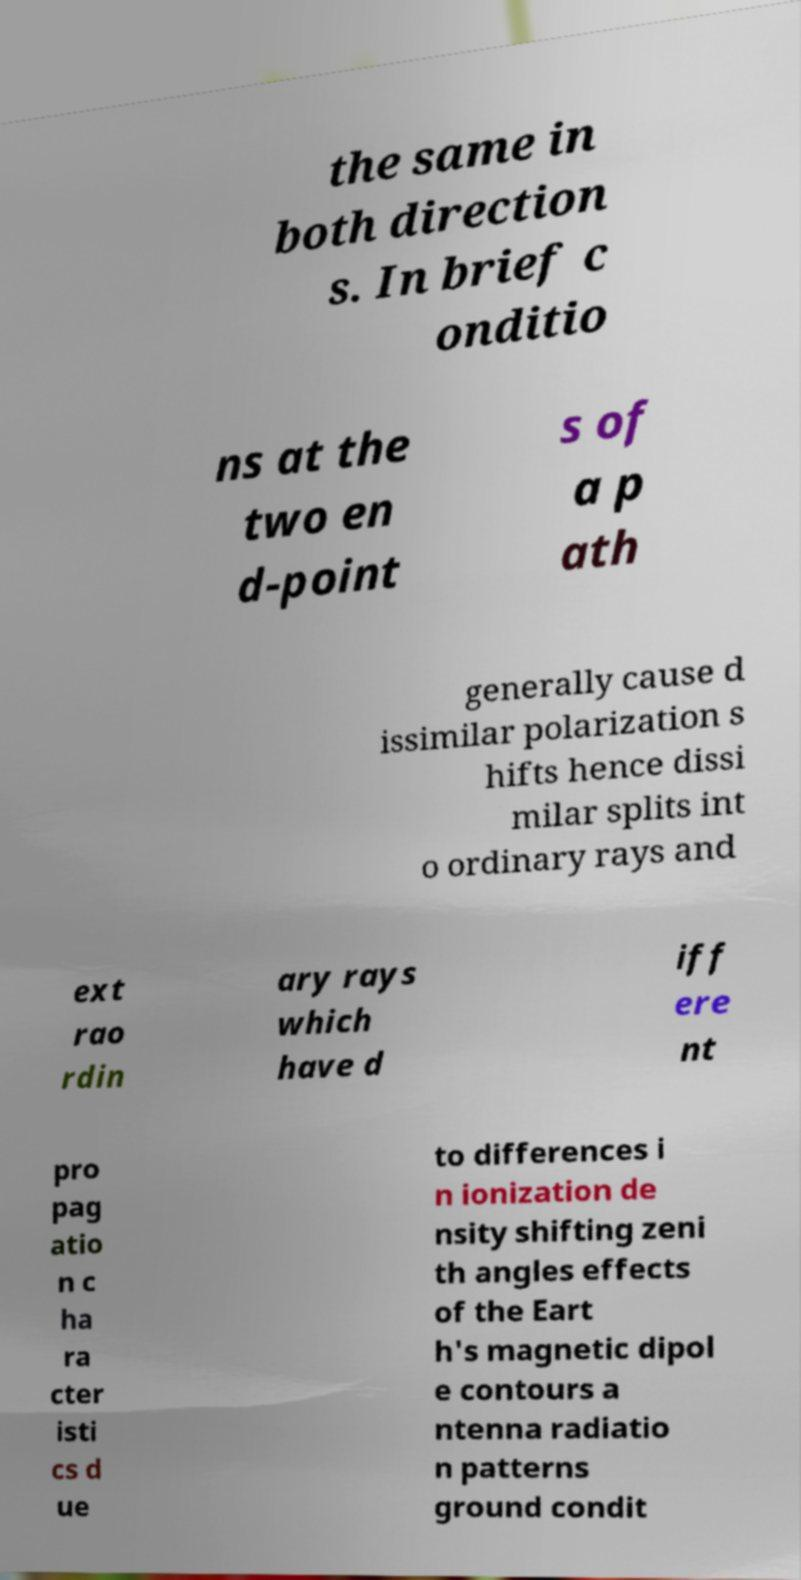What messages or text are displayed in this image? I need them in a readable, typed format. the same in both direction s. In brief c onditio ns at the two en d-point s of a p ath generally cause d issimilar polarization s hifts hence dissi milar splits int o ordinary rays and ext rao rdin ary rays which have d iff ere nt pro pag atio n c ha ra cter isti cs d ue to differences i n ionization de nsity shifting zeni th angles effects of the Eart h's magnetic dipol e contours a ntenna radiatio n patterns ground condit 